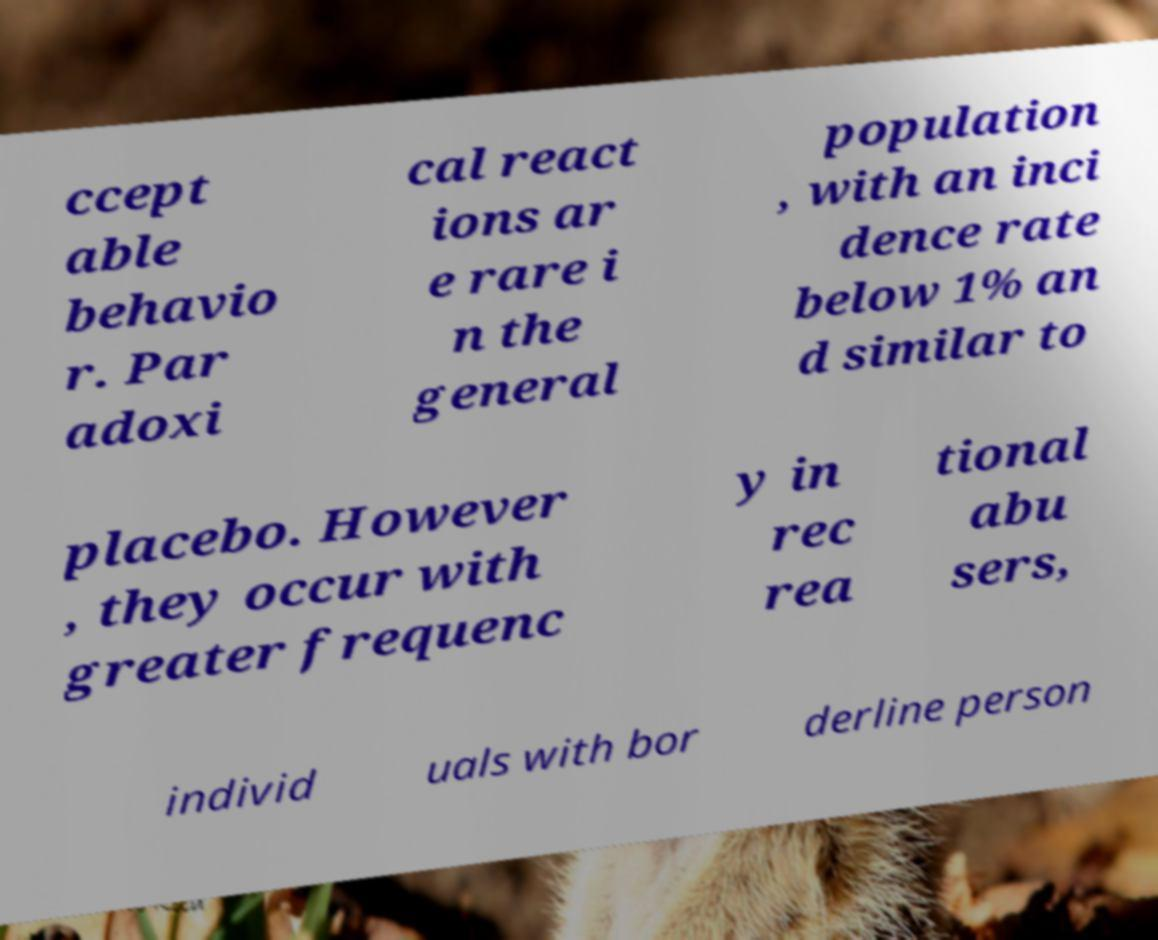Please identify and transcribe the text found in this image. ccept able behavio r. Par adoxi cal react ions ar e rare i n the general population , with an inci dence rate below 1% an d similar to placebo. However , they occur with greater frequenc y in rec rea tional abu sers, individ uals with bor derline person 